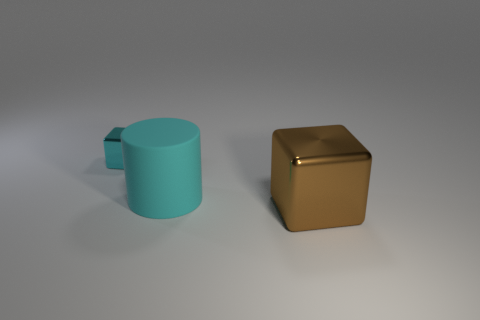Does the small shiny cube have the same color as the matte object?
Your answer should be very brief. Yes. Do the small cyan thing and the large cyan object have the same material?
Offer a terse response. No. There is a metallic object that is left of the large metallic block; is its color the same as the big rubber thing?
Give a very brief answer. Yes. How many tiny blocks are the same color as the big cylinder?
Your answer should be very brief. 1. How many big brown blocks are made of the same material as the large cyan cylinder?
Provide a short and direct response. 0. What is the size of the other brown thing that is the same shape as the tiny metal thing?
Offer a very short reply. Large. What is the big brown block made of?
Your answer should be compact. Metal. The block in front of the metallic object that is behind the metallic thing in front of the large rubber cylinder is made of what material?
Make the answer very short. Metal. Are there any other things that are the same shape as the rubber object?
Your response must be concise. No. What color is the other object that is the same shape as the small cyan object?
Provide a short and direct response. Brown. 